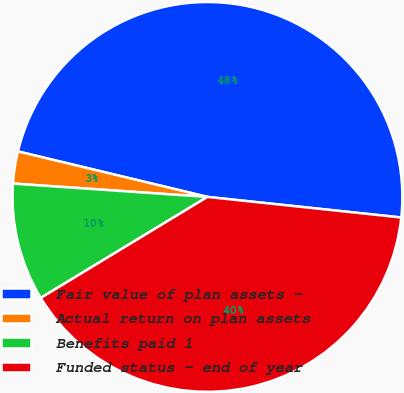Convert chart. <chart><loc_0><loc_0><loc_500><loc_500><pie_chart><fcel>Fair value of plan assets -<fcel>Actual return on plan assets<fcel>Benefits paid 1<fcel>Funded status - end of year<nl><fcel>47.93%<fcel>2.66%<fcel>9.76%<fcel>39.64%<nl></chart> 